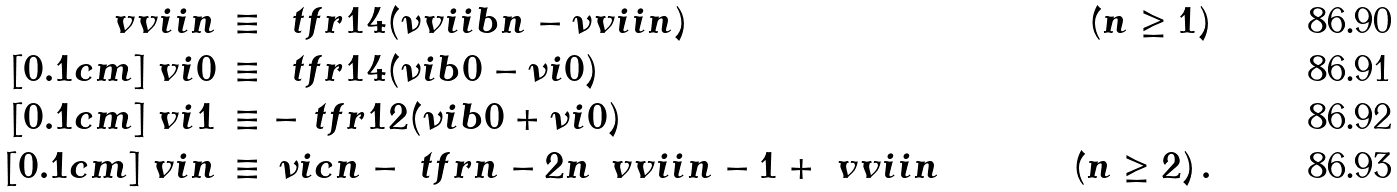<formula> <loc_0><loc_0><loc_500><loc_500>\ v v i i { n } & \, \equiv \, \ t f r { 1 } { 4 } ( \nu v i i b { n } - \nu v i i { n } ) & ( n \geq 1 ) \\ [ 0 . 1 c m ] \ v i { 0 } & \, \equiv \, \ t f r { 1 } { 4 } ( \nu i b { 0 } - \nu i { 0 } ) & \\ [ 0 . 1 c m ] \ v i { 1 } & \, \equiv - \ t f r { 1 } { 2 } ( \nu i b { 0 } + \nu i { 0 } ) & \\ [ 0 . 1 c m ] \ v i { n } & \, \equiv \, \nu i c { n } - \ t f r { n - 2 } { n } \, \ v v i i { n - 1 } + \ v v i i { n } \quad & ( n \geq 2 ) \, .</formula> 